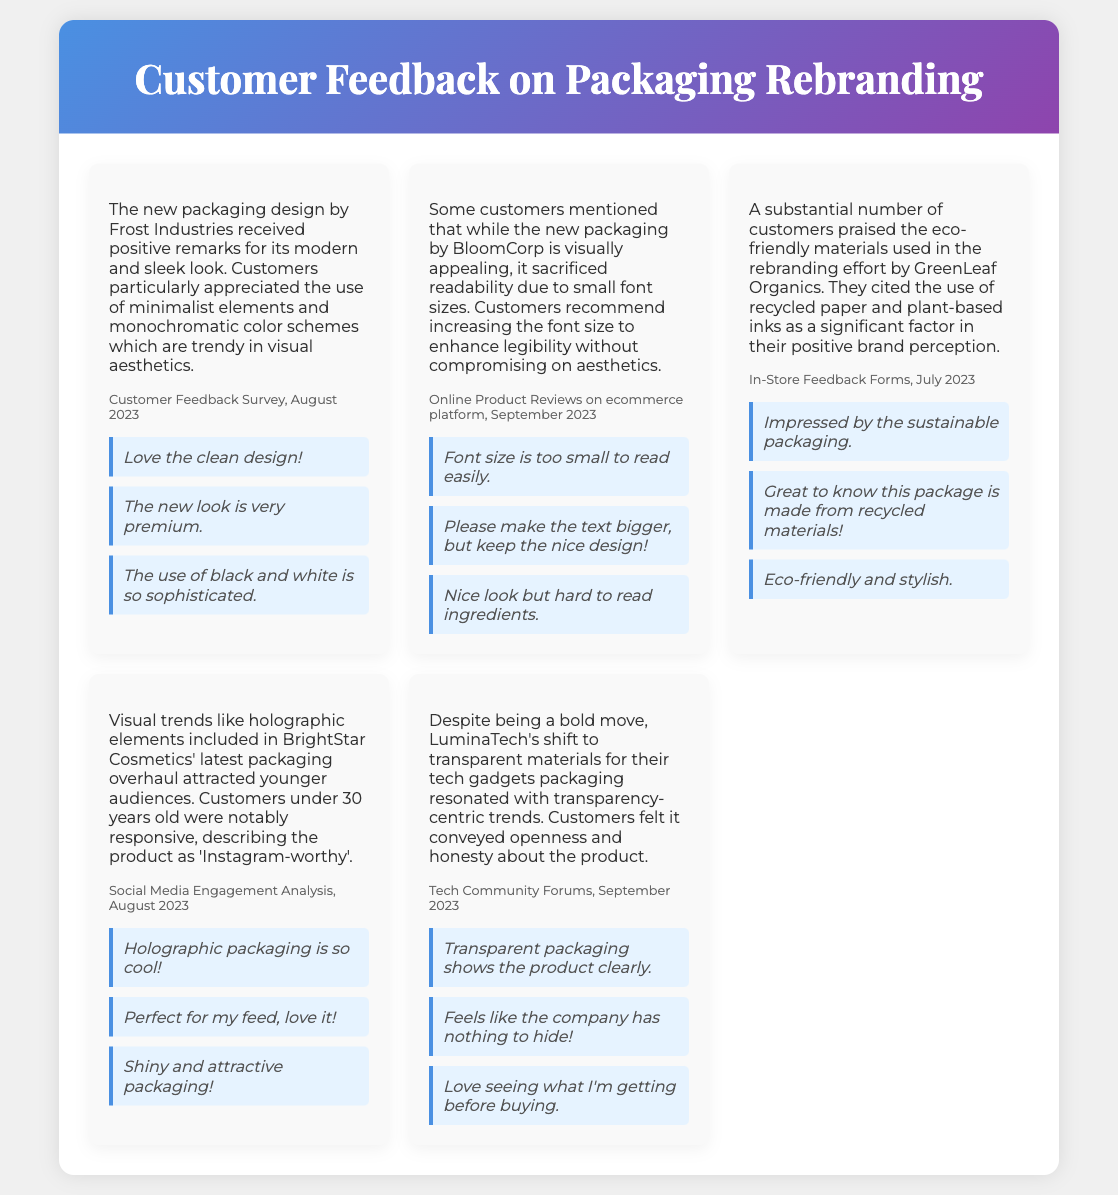What feedback did customers give about the packaging design by Frost Industries? Customers appreciated the modern and sleek look, particularly the minimalist elements and monochromatic color schemes.
Answer: Modern and sleek look What was a common critique of BloomCorp's packaging? Customers mentioned that the small font sizes sacrificed readability.
Answer: Small font sizes What environmentally friendly aspect did customers praise about GreenLeaf Organics' packaging? Customers cited the use of recycled paper and plant-based inks.
Answer: Recycled paper and plant-based inks Which visual trend attracted younger audiences to BrightStar Cosmetics' packaging? Holographic elements included in the packaging overhaul attracted younger audiences.
Answer: Holographic elements What was the general sentiment towards LuminaTech's transparent packaging? Customers felt the transparent packaging conveyed openness and honesty about the product.
Answer: Openness and honesty Which demographic found BrightStar Cosmetics' packaging to be 'Instagram-worthy'? Customers under 30 years old described the product as 'Instagram-worthy'.
Answer: Under 30 years old What source reported the feedback for Frost Industries' packaging design? The feedback was reported from a Customer Feedback Survey conducted in August 2023.
Answer: Customer Feedback Survey, August 2023 How did customers react to GreenLeaf Organics' use of eco-friendly materials? Customers were impressed by the sustainable packaging.
Answer: Impressed by sustainable packaging What aspect of LuminaTech's packaging resonated with current trends? The shift to transparent materials resonated with transparency-centric trends.
Answer: Transparent materials 